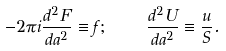<formula> <loc_0><loc_0><loc_500><loc_500>- 2 \pi i \frac { d ^ { 2 } F } { d a ^ { 2 } } \equiv f ; \quad \frac { d ^ { 2 } U } { d a ^ { 2 } } \equiv \frac { u } { S } .</formula> 